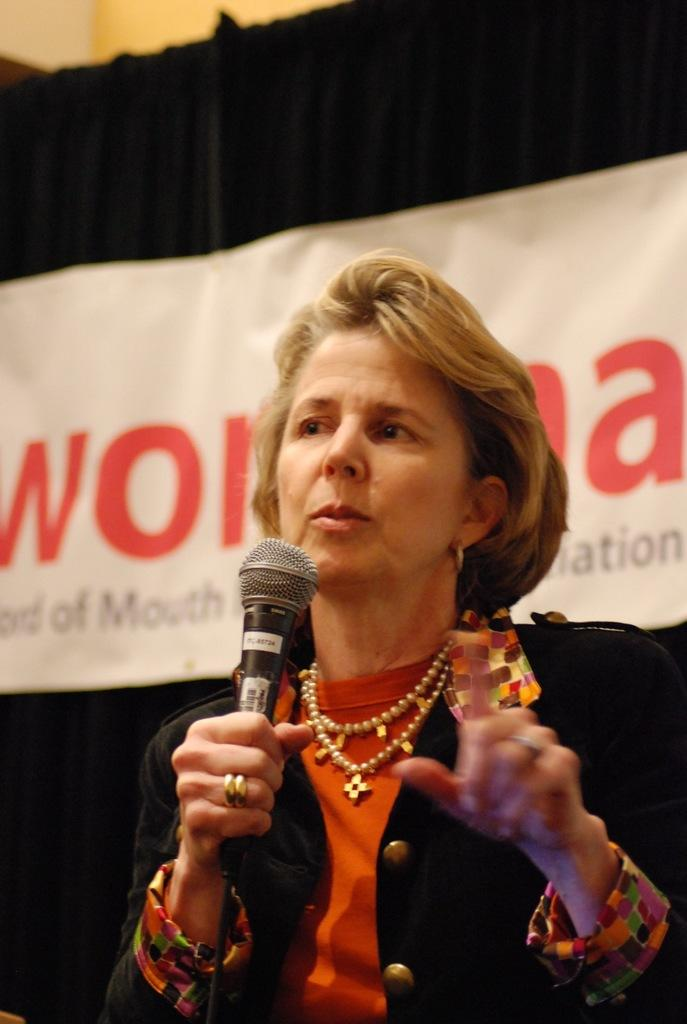Who is the main subject in the image? There is a lady in the center of the image. What is the lady holding in the image? The lady is holding a mic. What is the lady doing in the image? The lady is talking. What can be seen in the background of the image? There is a banner and cloth in the background of the image. What architectural feature is visible in the top left corner of the image? There is a wall at the top left corner of the image. What type of stocking is the lady wearing in the image? There is no mention of stockings or any clothing items in the image, so it is not possible to determine what type of stocking the lady might be wearing. 